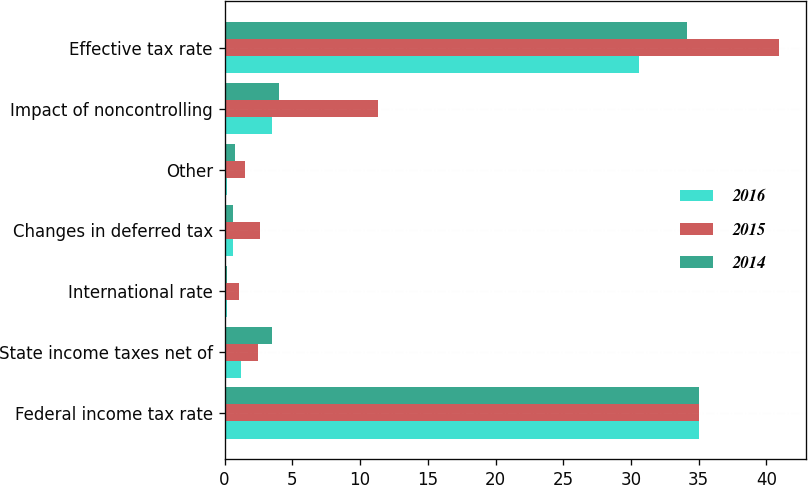Convert chart to OTSL. <chart><loc_0><loc_0><loc_500><loc_500><stacked_bar_chart><ecel><fcel>Federal income tax rate<fcel>State income taxes net of<fcel>International rate<fcel>Changes in deferred tax<fcel>Other<fcel>Impact of noncontrolling<fcel>Effective tax rate<nl><fcel>2016<fcel>35<fcel>1.2<fcel>0.2<fcel>0.6<fcel>0.2<fcel>3.5<fcel>30.6<nl><fcel>2015<fcel>35<fcel>2.5<fcel>1.1<fcel>2.6<fcel>1.5<fcel>11.3<fcel>40.9<nl><fcel>2014<fcel>35<fcel>3.5<fcel>0.2<fcel>0.6<fcel>0.8<fcel>4<fcel>34.1<nl></chart> 